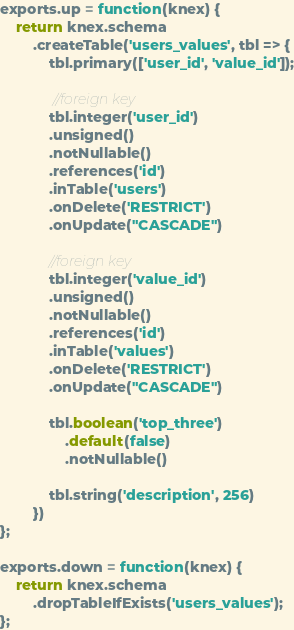<code> <loc_0><loc_0><loc_500><loc_500><_JavaScript_>
exports.up = function(knex) {
    return knex.schema
        .createTable('users_values', tbl => {
            tbl.primary(['user_id', 'value_id']);

             //foreign key
            tbl.integer('user_id')
            .unsigned()
            .notNullable()
            .references('id')
            .inTable('users')
            .onDelete('RESTRICT')
            .onUpdate("CASCADE")

            //foreign key
            tbl.integer('value_id')
            .unsigned()
            .notNullable()
            .references('id')
            .inTable('values')
            .onDelete('RESTRICT')
            .onUpdate("CASCADE")

            tbl.boolean('top_three')
                .default(false)
                .notNullable()

            tbl.string('description', 256)
        })
};

exports.down = function(knex) {
    return knex.schema
        .dropTableIfExists('users_values');
};
</code> 